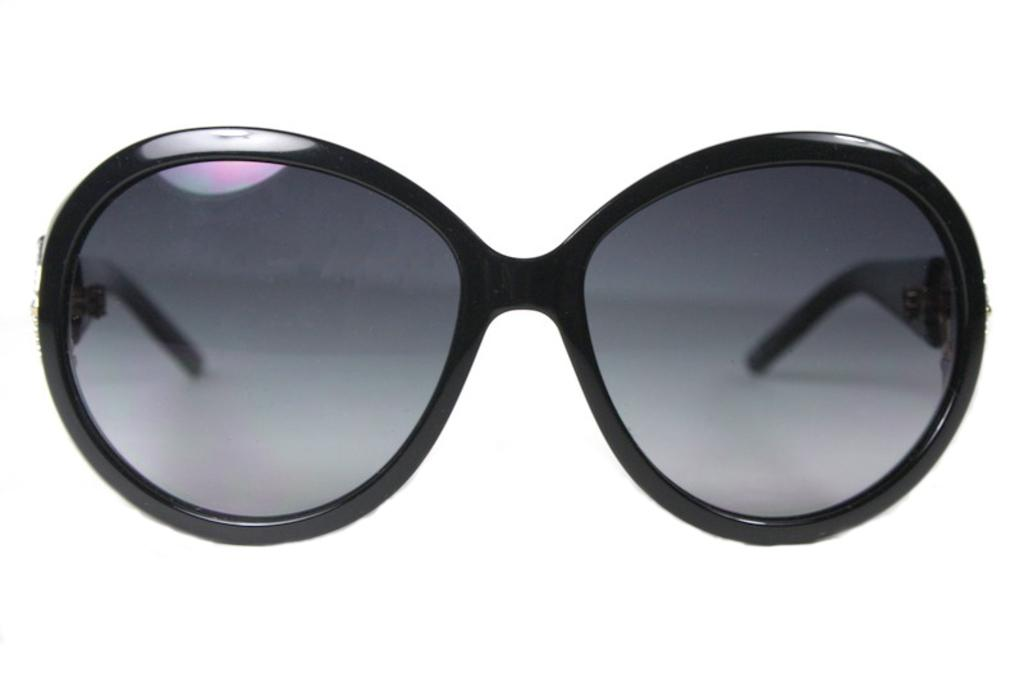What type of protective eyewear is visible in the image? There are goggles in the image. Where are the goggles placed in the image? The goggles are on a white surface. What color is the background of the image? The background of the image is white. What type of stick can be seen growing out of the earth in the image? There is no stick or earth present in the image; it only features goggles on a white surface with a white background. 